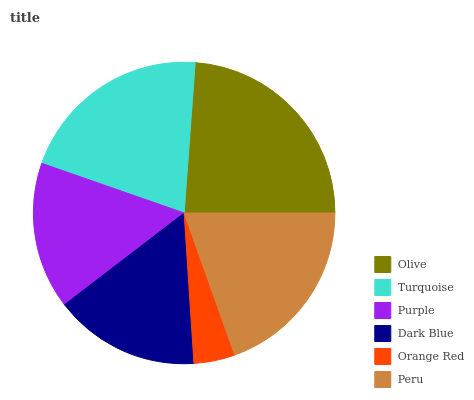Is Orange Red the minimum?
Answer yes or no. Yes. Is Olive the maximum?
Answer yes or no. Yes. Is Turquoise the minimum?
Answer yes or no. No. Is Turquoise the maximum?
Answer yes or no. No. Is Olive greater than Turquoise?
Answer yes or no. Yes. Is Turquoise less than Olive?
Answer yes or no. Yes. Is Turquoise greater than Olive?
Answer yes or no. No. Is Olive less than Turquoise?
Answer yes or no. No. Is Peru the high median?
Answer yes or no. Yes. Is Purple the low median?
Answer yes or no. Yes. Is Orange Red the high median?
Answer yes or no. No. Is Turquoise the low median?
Answer yes or no. No. 